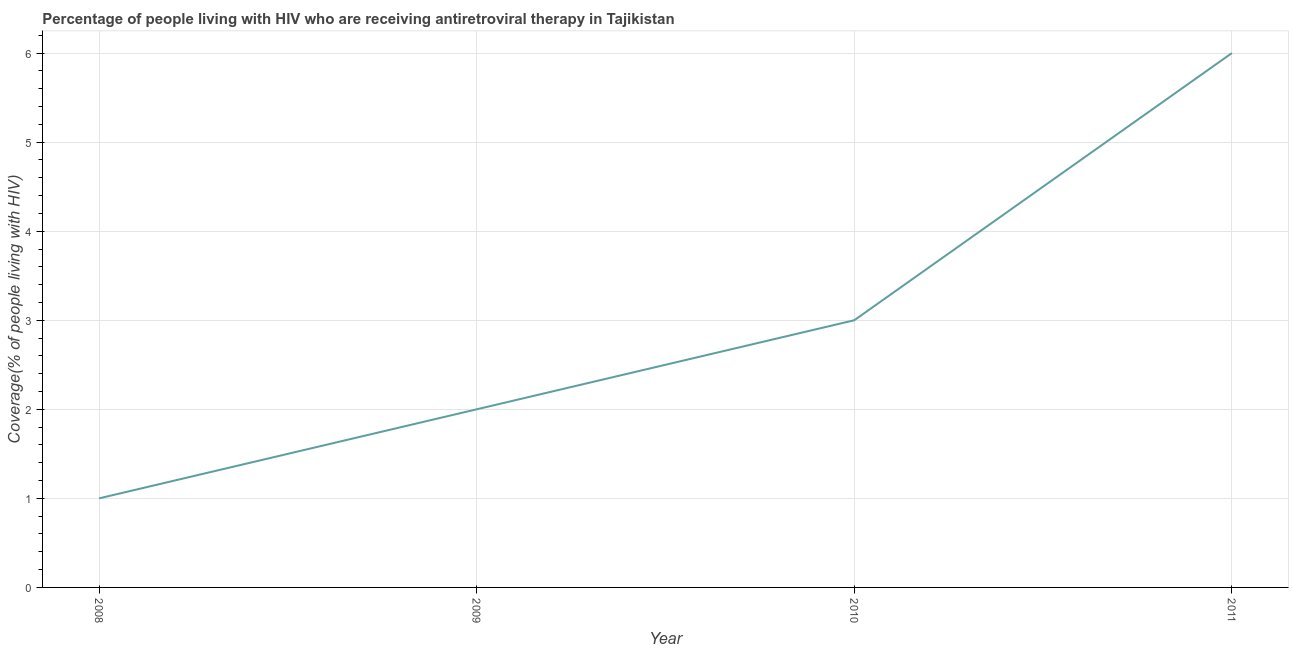What is the antiretroviral therapy coverage in 2009?
Your answer should be very brief. 2. Across all years, what is the minimum antiretroviral therapy coverage?
Ensure brevity in your answer.  1. In which year was the antiretroviral therapy coverage maximum?
Keep it short and to the point. 2011. What is the sum of the antiretroviral therapy coverage?
Your response must be concise. 12. What is the difference between the antiretroviral therapy coverage in 2008 and 2011?
Your response must be concise. -5. What is the average antiretroviral therapy coverage per year?
Make the answer very short. 3. What is the median antiretroviral therapy coverage?
Give a very brief answer. 2.5. In how many years, is the antiretroviral therapy coverage greater than 0.2 %?
Your answer should be very brief. 4. What is the difference between the highest and the second highest antiretroviral therapy coverage?
Provide a succinct answer. 3. Is the sum of the antiretroviral therapy coverage in 2008 and 2009 greater than the maximum antiretroviral therapy coverage across all years?
Keep it short and to the point. No. What is the difference between the highest and the lowest antiretroviral therapy coverage?
Offer a terse response. 5. Does the antiretroviral therapy coverage monotonically increase over the years?
Ensure brevity in your answer.  Yes. How many years are there in the graph?
Make the answer very short. 4. What is the difference between two consecutive major ticks on the Y-axis?
Your answer should be very brief. 1. Are the values on the major ticks of Y-axis written in scientific E-notation?
Keep it short and to the point. No. Does the graph contain any zero values?
Offer a terse response. No. What is the title of the graph?
Provide a short and direct response. Percentage of people living with HIV who are receiving antiretroviral therapy in Tajikistan. What is the label or title of the X-axis?
Your response must be concise. Year. What is the label or title of the Y-axis?
Provide a short and direct response. Coverage(% of people living with HIV). What is the Coverage(% of people living with HIV) of 2008?
Your answer should be very brief. 1. What is the difference between the Coverage(% of people living with HIV) in 2008 and 2009?
Make the answer very short. -1. What is the difference between the Coverage(% of people living with HIV) in 2009 and 2010?
Offer a terse response. -1. What is the difference between the Coverage(% of people living with HIV) in 2009 and 2011?
Offer a very short reply. -4. What is the difference between the Coverage(% of people living with HIV) in 2010 and 2011?
Make the answer very short. -3. What is the ratio of the Coverage(% of people living with HIV) in 2008 to that in 2010?
Keep it short and to the point. 0.33. What is the ratio of the Coverage(% of people living with HIV) in 2008 to that in 2011?
Keep it short and to the point. 0.17. What is the ratio of the Coverage(% of people living with HIV) in 2009 to that in 2010?
Your answer should be very brief. 0.67. What is the ratio of the Coverage(% of people living with HIV) in 2009 to that in 2011?
Offer a very short reply. 0.33. 